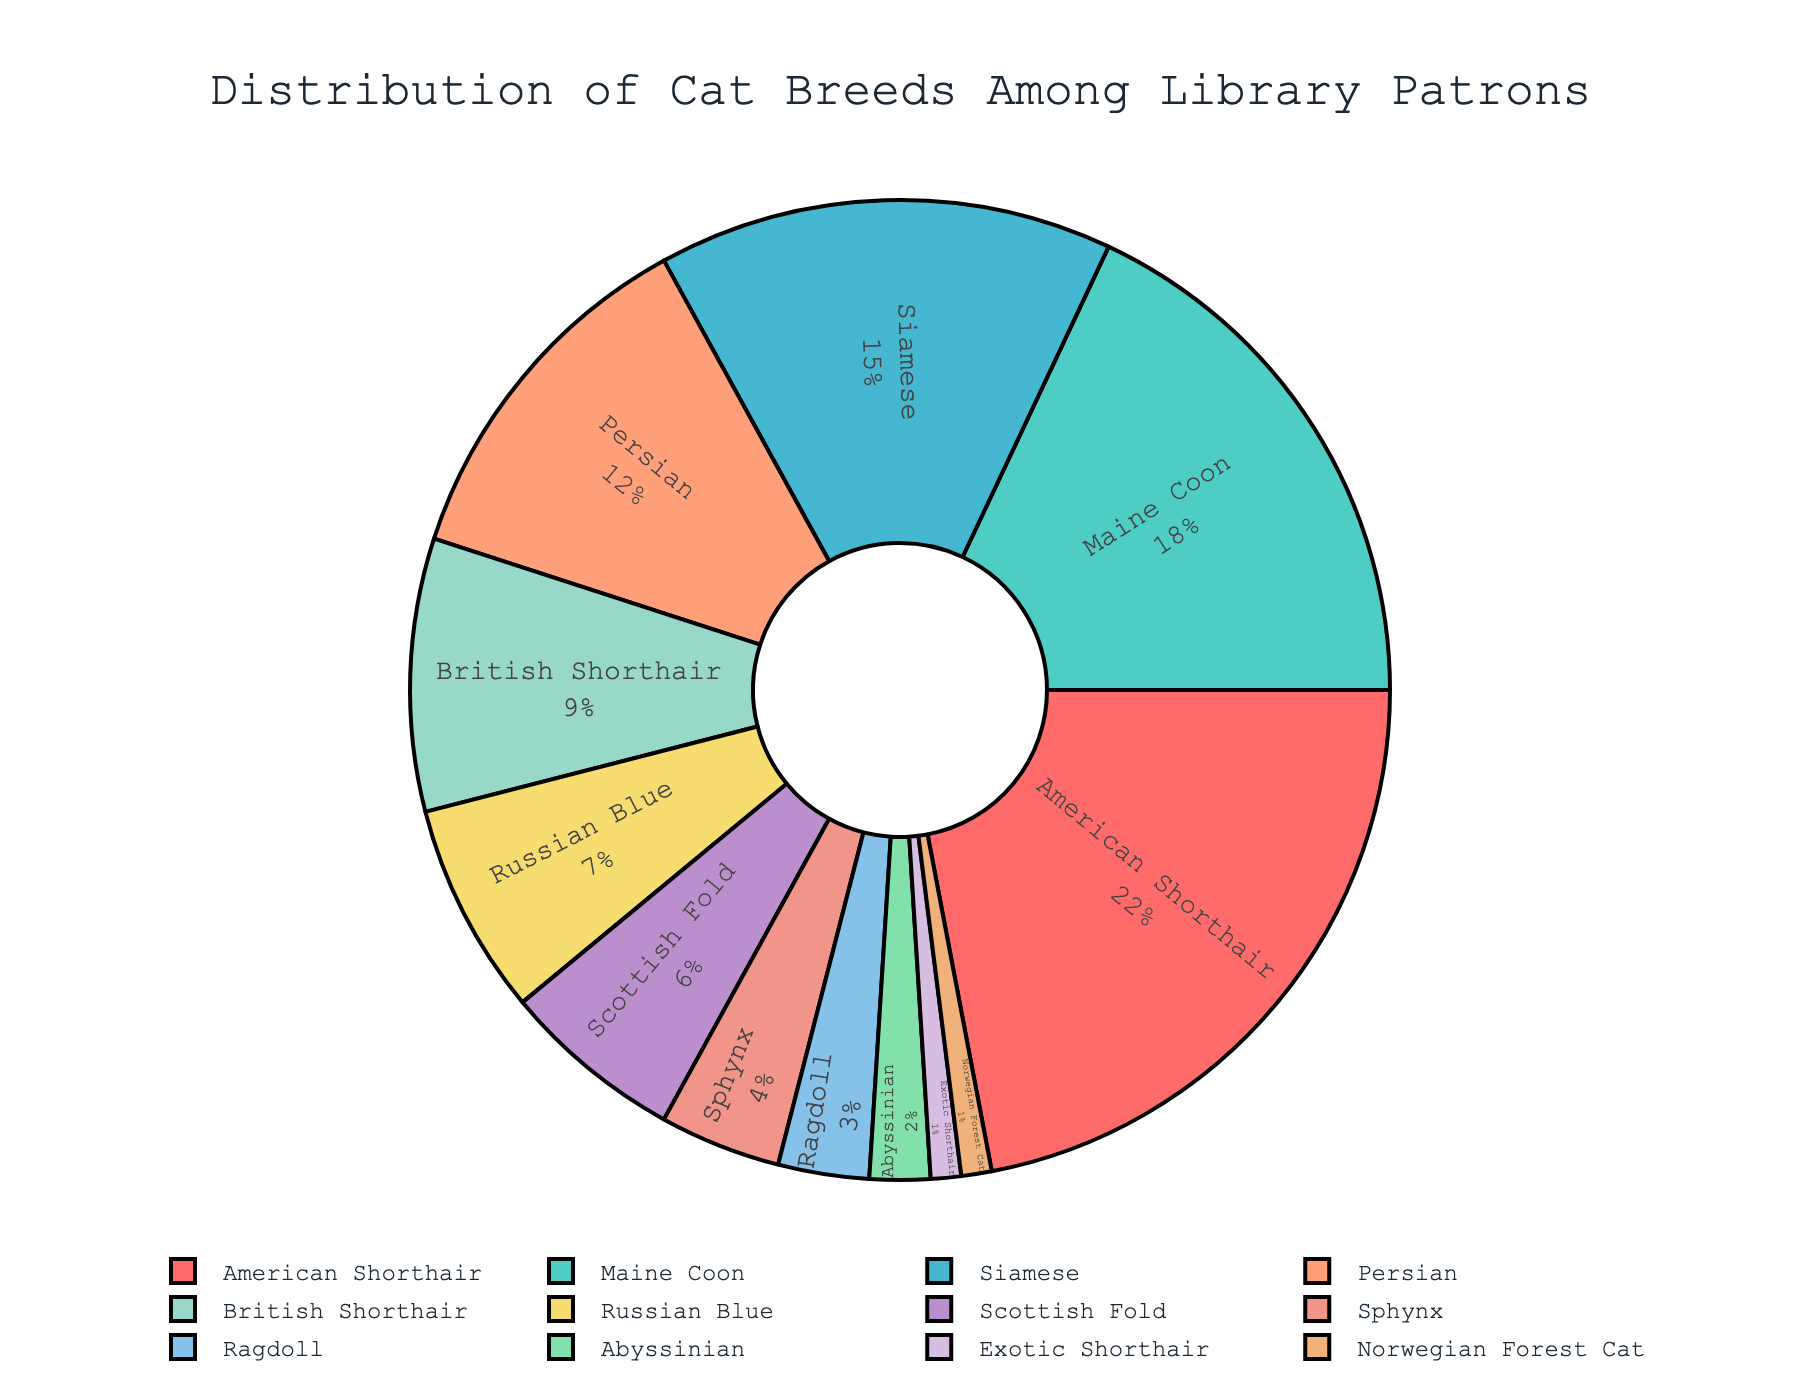Which cat breed has the highest percentage among library patrons? The American Shorthair breed is the largest segment in the pie chart, indicated by its label and percentage.
Answer: American Shorthair What is the combined percentage of Maine Coon and Siamese breeds? The pie chart shows Maine Coon at 18% and Siamese at 15%. Adding these together gives 18% + 15% = 33%.
Answer: 33% Which has a higher percentage, Persian or British Shorthair? The pie chart shows that Persian has 12% and British Shorthair has 9%. Comparing these, Persian has a higher percentage than British Shorthair.
Answer: Persian What is the total percentage of the three least common breeds? The least common breeds are Exotic Shorthair (1%), Norwegian Forest Cat (1%), and Abyssinian (2%). Adding these together results in 1% + 1% + 2% = 4%.
Answer: 4% How does the percentage of Russian Blue compare to Scottish Fold? The pie chart shows Russian Blue at 7% and Scottish Fold at 6%. Comparing these, Russian Blue has a higher percentage than Scottish Fold.
Answer: Russian Blue What's the difference in percentage between the Ragdoll and Sphynx breeds? The pie chart shows Ragdoll at 3% and Sphynx at 4%. The difference is 4% - 3% = 1%.
Answer: 1% What is the average percentage of the top 4 breeds? The top 4 breeds are American Shorthair (22%), Maine Coon (18%), Siamese (15%), and Persian (12%). Adding these together gives 22% + 18% + 15% + 12% = 67%. Dividing by 4 yields 67% / 4 = 16.75%.
Answer: 16.75% Which breeds have percentages that are below the median percentage of all breeds? There are 12 breeds, so the median breed is the 6th and 7th sorted breed. Sorting gives [1%, 1%, 2%, 3%, 4%, 6%, 7%, 9%, 12%, 15%, 18%, 22%]. The median is (6% + 7%) / 2 = 6.5%. Breeds below this are Exotic Shorthair, Norwegian Forest Cat, Abyssinian, Ragdoll, and Sphynx.
Answer: Exotic Shorthair, Norwegian Forest Cat, Abyssinian, Ragdoll, Sphynx What is the sum of the percentages of Abyssinian, Exotic Shorthair, and Norwegian Forest Cat? The pie chart shows Abyssinian at 2%, Exotic Shorthair at 1%, and Norwegian Forest Cat at 1%. Adding these gives 2% + 1% + 1% = 4%.
Answer: 4% What color represents the Persian breed in the pie chart? The segment for the Persian breed is in a peach-like color, denoted by the assigned color scheme in the visual.
Answer: peach 